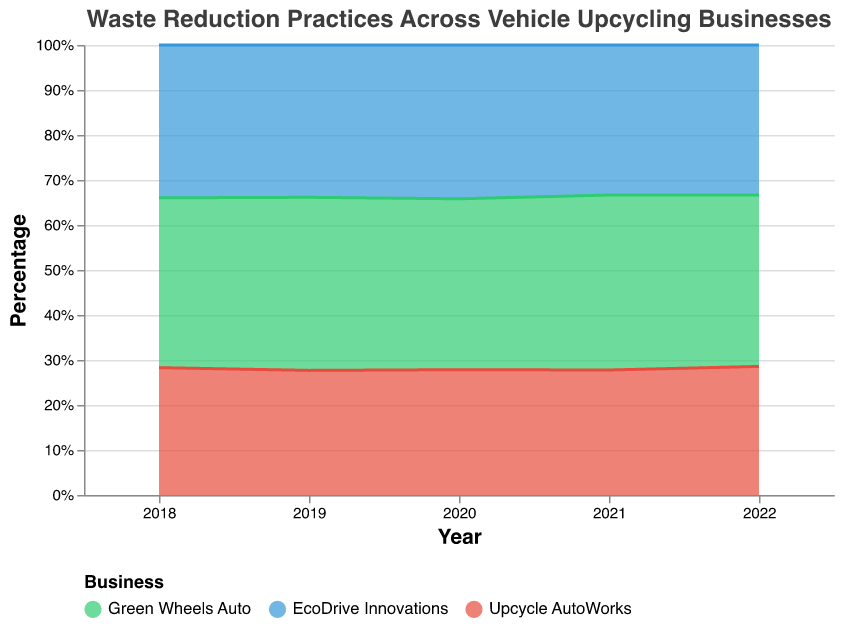What is the primary waste reduction practice of Green Wheels Auto in 2022? By examining the largest area for Green Wheels Auto in 2022, it is evident that Metal Recycling occupies the majority.
Answer: Metal Recycling Which business had the highest percentage of Textile Repurposing in 2020? The business with the highest area in the Textile Repurposing segment for 2020 is EcoDrive Innovations.
Answer: EcoDrive Innovations How does the percentage of Electronic Waste Management change for Upcycle AutoWorks from 2018 to 2022? In 2018, the area for Electronic Waste Management for Upcycle AutoWorks is significant but decreases gradually each year until it is smaller in 2022.
Answer: Decreases Compare the Plastic Reduction practices of EcoDrive Innovations and Upcycle AutoWorks in 2021. Which one devoted a higher percentage? By comparing the areas representing Plastic Reduction for both companies in 2021, Upcycle AutoWorks shows a larger area, indicating a higher percentage.
Answer: Upcycle AutoWorks What trend do you observe in the sum of the percentages for Other Waste Reduction Practices across all businesses from 2018 to 2022? Summing up the areas for Other Waste Reduction Practices across all businesses, it is noticeable that this practice decreases gradually year by year towards zero.
Answer: Decreases What is the total percentage of Metal Recycling and Plastic Reduction for Green Wheels Auto in 2021? Summing up the percentages for Metal Recycling (35%) and Plastic Reduction (18%) for Green Wheels Auto in 2021 gives a total.
Answer: 53% Which year shows the highest involvement in Textile Repurposing for all businesses combined? The year with the largest combined area for Textile Repurposing across all businesses is 2022.
Answer: 2022 How does Green Wheels Auto's approach to Plastic Reduction change from 2018 to 2022? Observing Green Wheels Auto, the area for Plastic Reduction gradually increases from 2018 to 2022.
Answer: Increases 